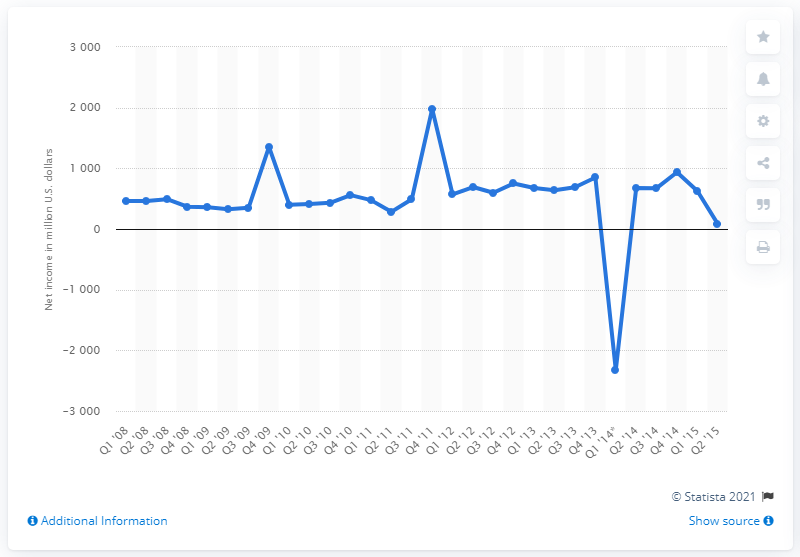Draw attention to some important aspects in this diagram. In the second quarter of 2015, eBay's net income was $83 million. 